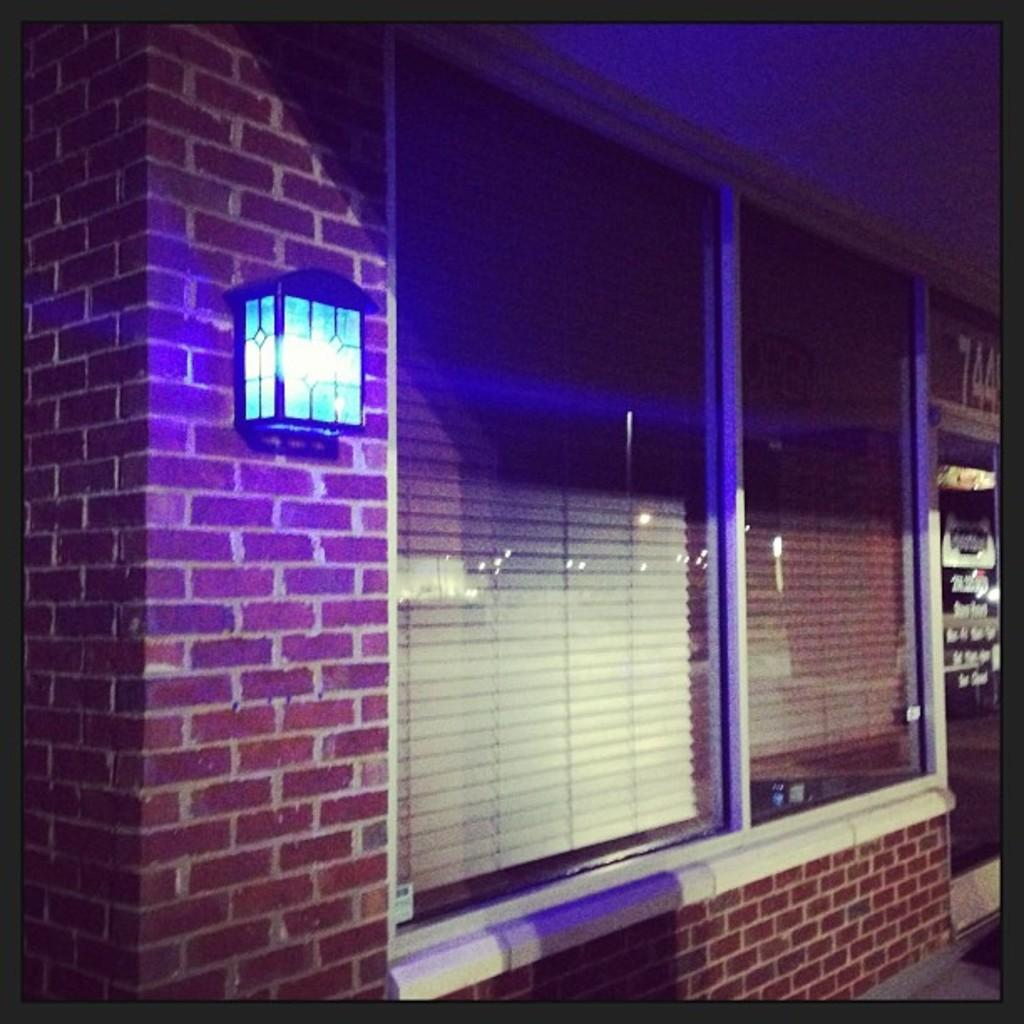What type of structure is visible in the image? There is a brick wall in the image. What can be seen attached to the brick wall? There is a lamp attached to the brick wall. What feature allows light to enter the building in the image? Glass windows are present in the image. What type of window covering is visible through the glass windows? Window blinds are visible through the glass windows. What type of establishment can be seen in the background of the image? There is a store in the background of the image. What type of jam is being sold in the store in the image? There is no indication of any jam being sold in the store in the image. Are there any dogs visible in the image? No, there are no dogs present in the image. 